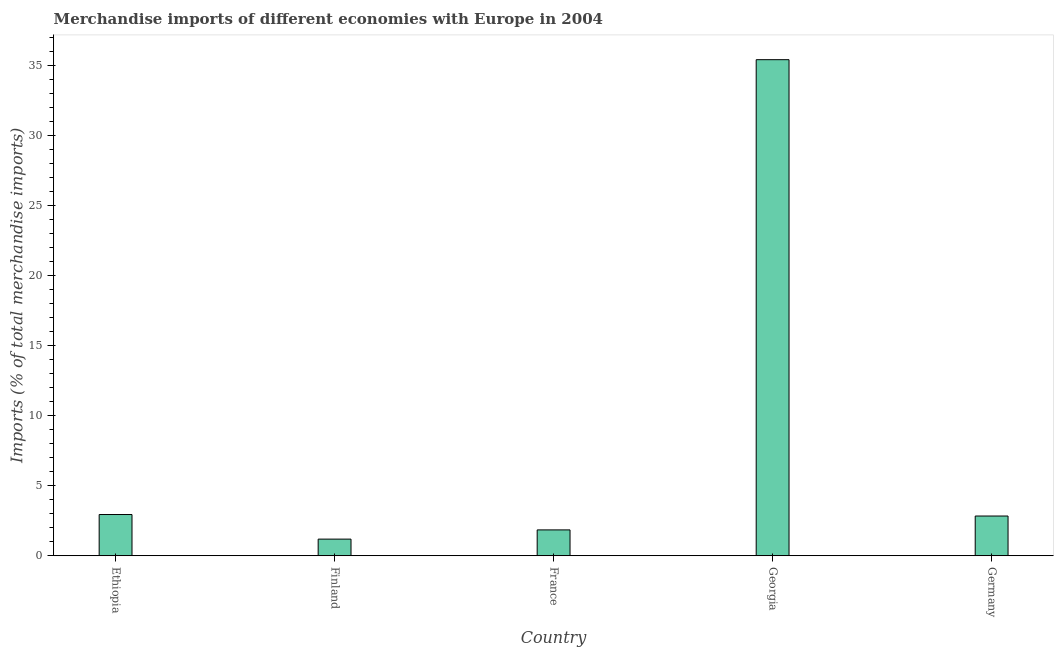What is the title of the graph?
Provide a succinct answer. Merchandise imports of different economies with Europe in 2004. What is the label or title of the X-axis?
Offer a terse response. Country. What is the label or title of the Y-axis?
Ensure brevity in your answer.  Imports (% of total merchandise imports). What is the merchandise imports in Georgia?
Provide a short and direct response. 35.44. Across all countries, what is the maximum merchandise imports?
Ensure brevity in your answer.  35.44. Across all countries, what is the minimum merchandise imports?
Your answer should be compact. 1.19. In which country was the merchandise imports maximum?
Your response must be concise. Georgia. In which country was the merchandise imports minimum?
Provide a succinct answer. Finland. What is the sum of the merchandise imports?
Offer a very short reply. 44.26. What is the difference between the merchandise imports in Ethiopia and Finland?
Your response must be concise. 1.76. What is the average merchandise imports per country?
Keep it short and to the point. 8.85. What is the median merchandise imports?
Make the answer very short. 2.84. In how many countries, is the merchandise imports greater than 3 %?
Provide a succinct answer. 1. What is the ratio of the merchandise imports in Finland to that in Germany?
Your answer should be compact. 0.42. What is the difference between the highest and the second highest merchandise imports?
Give a very brief answer. 32.49. Is the sum of the merchandise imports in France and Germany greater than the maximum merchandise imports across all countries?
Make the answer very short. No. What is the difference between the highest and the lowest merchandise imports?
Your answer should be compact. 34.24. In how many countries, is the merchandise imports greater than the average merchandise imports taken over all countries?
Your answer should be compact. 1. How many bars are there?
Your answer should be very brief. 5. Are all the bars in the graph horizontal?
Keep it short and to the point. No. How many countries are there in the graph?
Your response must be concise. 5. What is the difference between two consecutive major ticks on the Y-axis?
Your answer should be compact. 5. Are the values on the major ticks of Y-axis written in scientific E-notation?
Your answer should be compact. No. What is the Imports (% of total merchandise imports) in Ethiopia?
Your answer should be compact. 2.95. What is the Imports (% of total merchandise imports) in Finland?
Your answer should be compact. 1.19. What is the Imports (% of total merchandise imports) of France?
Your answer should be compact. 1.85. What is the Imports (% of total merchandise imports) of Georgia?
Your response must be concise. 35.44. What is the Imports (% of total merchandise imports) in Germany?
Offer a terse response. 2.84. What is the difference between the Imports (% of total merchandise imports) in Ethiopia and Finland?
Offer a very short reply. 1.76. What is the difference between the Imports (% of total merchandise imports) in Ethiopia and France?
Make the answer very short. 1.1. What is the difference between the Imports (% of total merchandise imports) in Ethiopia and Georgia?
Provide a succinct answer. -32.49. What is the difference between the Imports (% of total merchandise imports) in Ethiopia and Germany?
Give a very brief answer. 0.11. What is the difference between the Imports (% of total merchandise imports) in Finland and France?
Your answer should be compact. -0.66. What is the difference between the Imports (% of total merchandise imports) in Finland and Georgia?
Keep it short and to the point. -34.24. What is the difference between the Imports (% of total merchandise imports) in Finland and Germany?
Your response must be concise. -1.65. What is the difference between the Imports (% of total merchandise imports) in France and Georgia?
Your answer should be compact. -33.59. What is the difference between the Imports (% of total merchandise imports) in France and Germany?
Ensure brevity in your answer.  -0.99. What is the difference between the Imports (% of total merchandise imports) in Georgia and Germany?
Provide a short and direct response. 32.59. What is the ratio of the Imports (% of total merchandise imports) in Ethiopia to that in Finland?
Keep it short and to the point. 2.48. What is the ratio of the Imports (% of total merchandise imports) in Ethiopia to that in France?
Provide a short and direct response. 1.59. What is the ratio of the Imports (% of total merchandise imports) in Ethiopia to that in Georgia?
Give a very brief answer. 0.08. What is the ratio of the Imports (% of total merchandise imports) in Finland to that in France?
Your answer should be compact. 0.64. What is the ratio of the Imports (% of total merchandise imports) in Finland to that in Georgia?
Ensure brevity in your answer.  0.03. What is the ratio of the Imports (% of total merchandise imports) in Finland to that in Germany?
Give a very brief answer. 0.42. What is the ratio of the Imports (% of total merchandise imports) in France to that in Georgia?
Your response must be concise. 0.05. What is the ratio of the Imports (% of total merchandise imports) in France to that in Germany?
Your answer should be compact. 0.65. What is the ratio of the Imports (% of total merchandise imports) in Georgia to that in Germany?
Offer a very short reply. 12.47. 